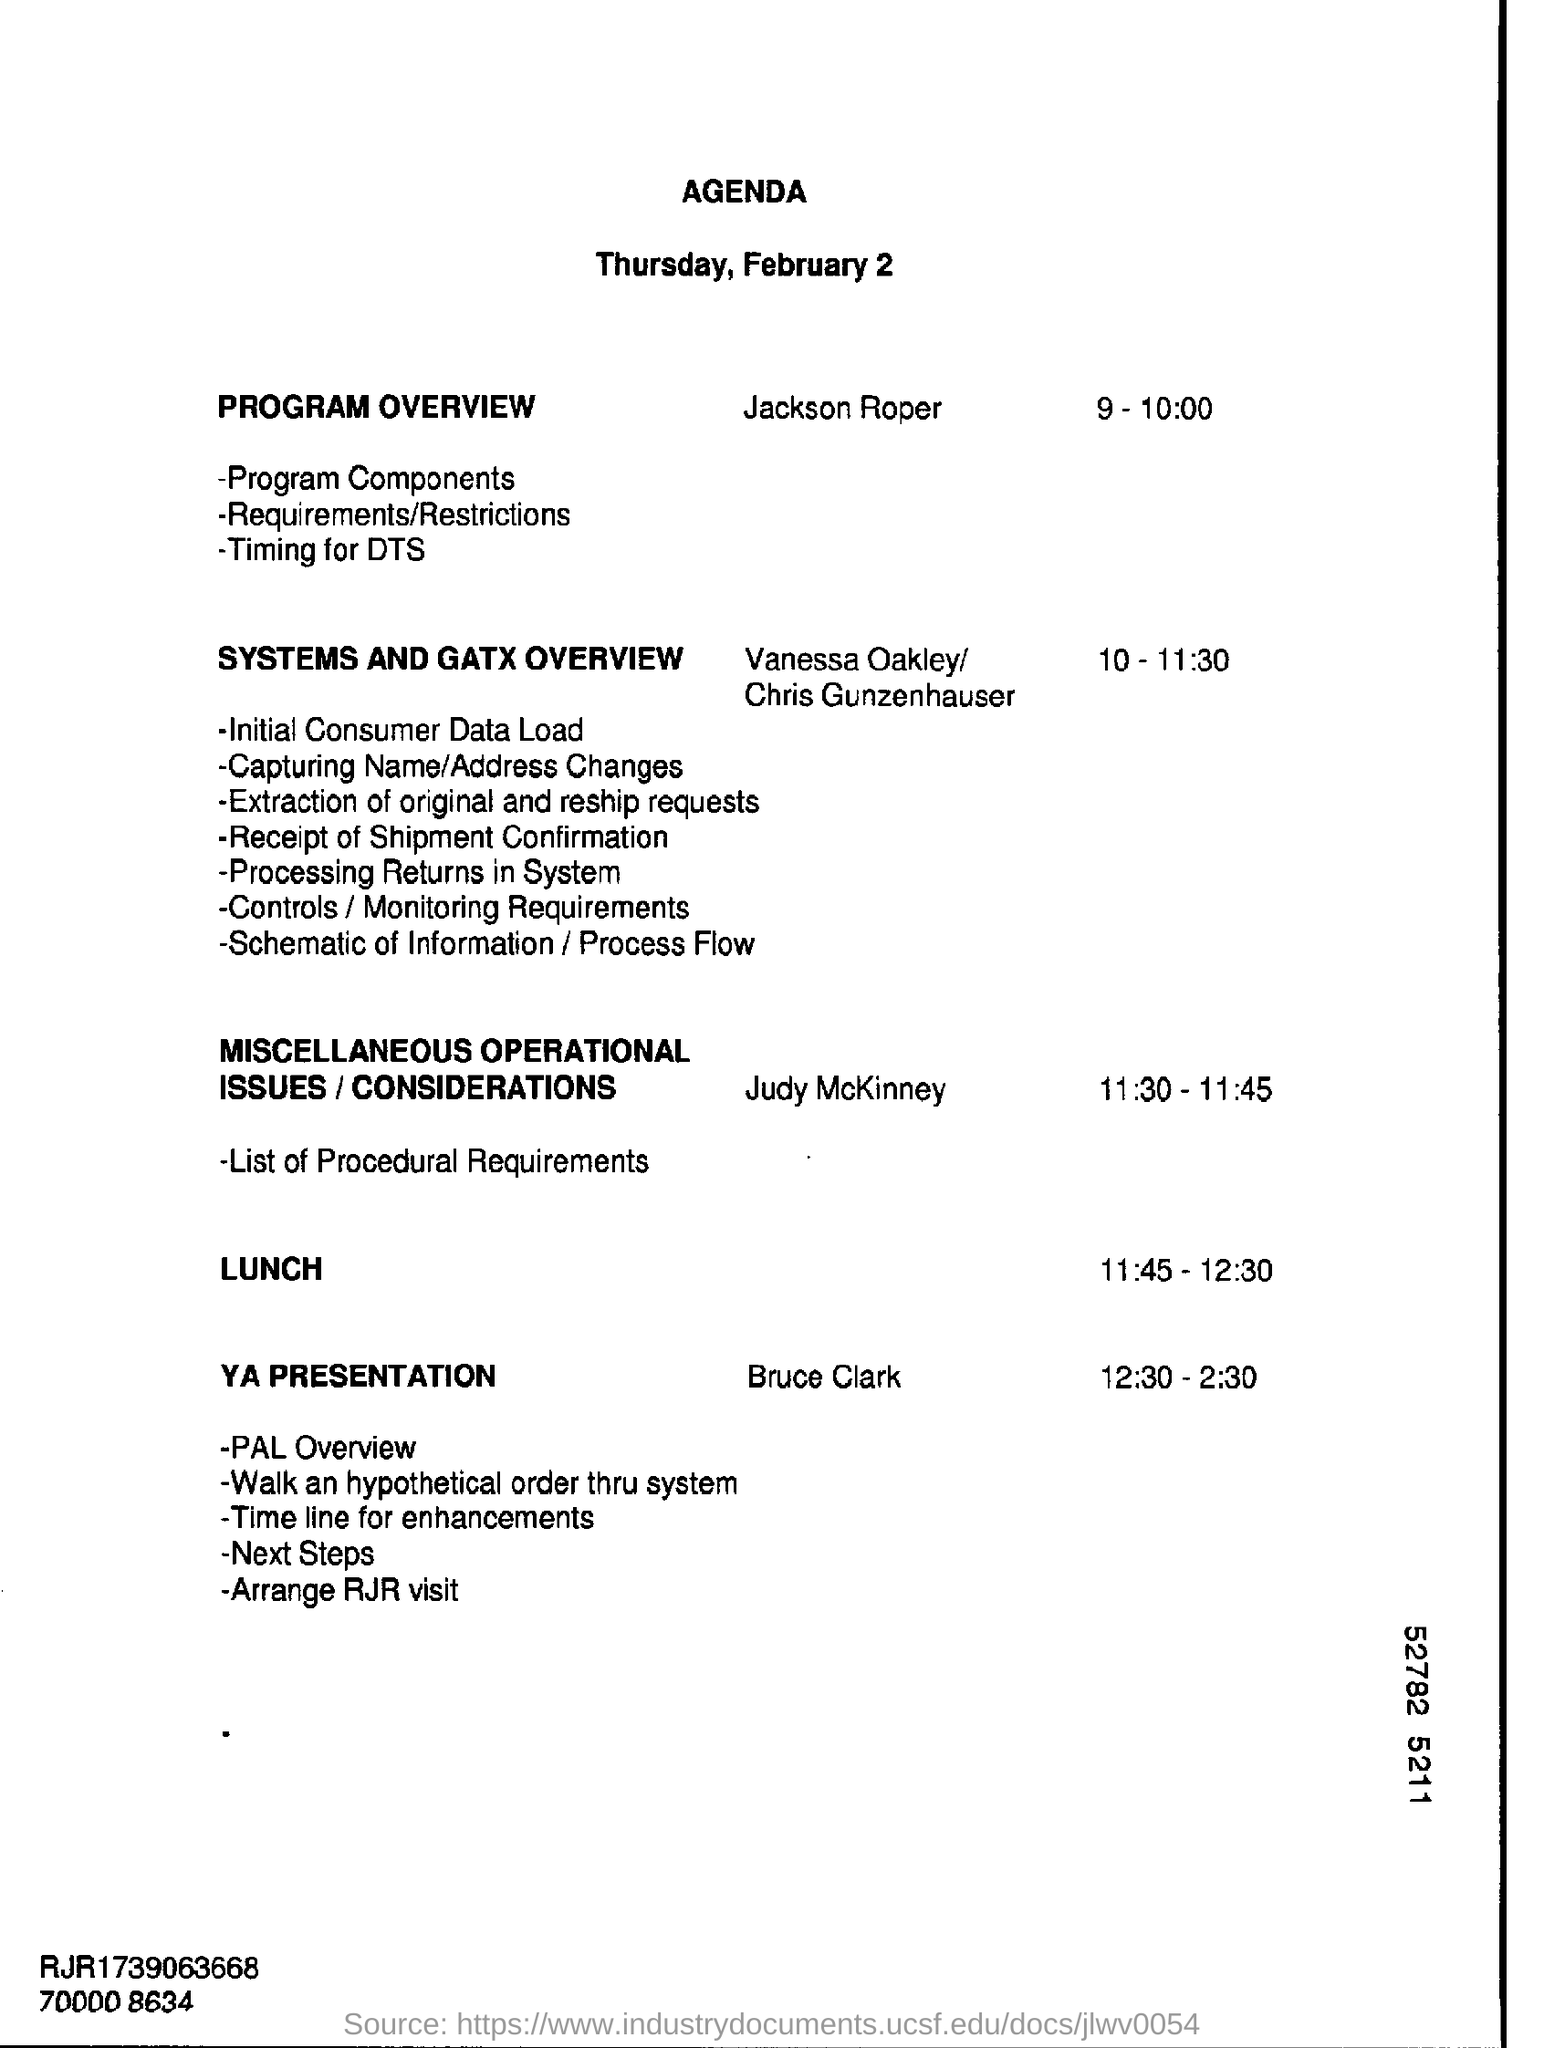What is the Title of the document ?
Your response must be concise. Agenda. What is the date mentioned in the document?
Offer a very short reply. Thursday, February 2. What is the Lunch Time ?
Provide a succinct answer. 11.45-12.30. 